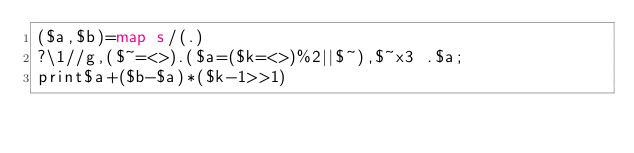<code> <loc_0><loc_0><loc_500><loc_500><_Perl_>($a,$b)=map s/(.)
?\1//g,($~=<>).($a=($k=<>)%2||$~),$~x3 .$a;
print$a+($b-$a)*($k-1>>1)</code> 